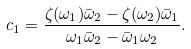Convert formula to latex. <formula><loc_0><loc_0><loc_500><loc_500>c _ { 1 } = \frac { \zeta ( \omega _ { 1 } ) \bar { \omega } _ { 2 } - \zeta ( \omega _ { 2 } ) \bar { \omega } _ { 1 } } { \omega _ { 1 } \bar { \omega } _ { 2 } - \bar { \omega } _ { 1 } \omega _ { 2 } } .</formula> 